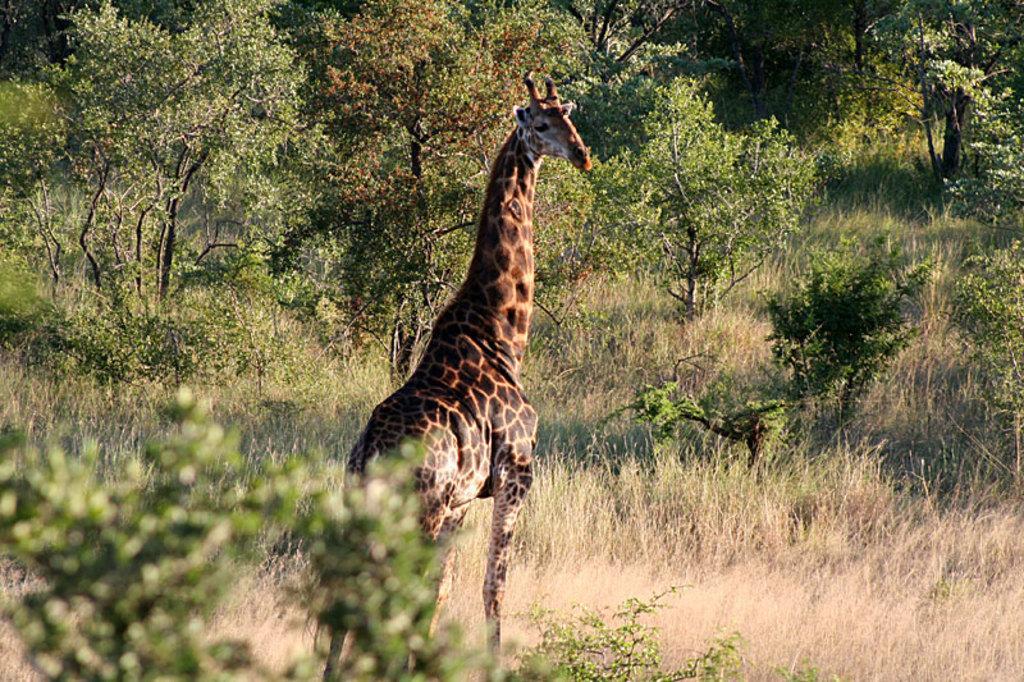Could you give a brief overview of what you see in this image? In this image I see a giraffe over here and I see the grass, plants and the trees. 